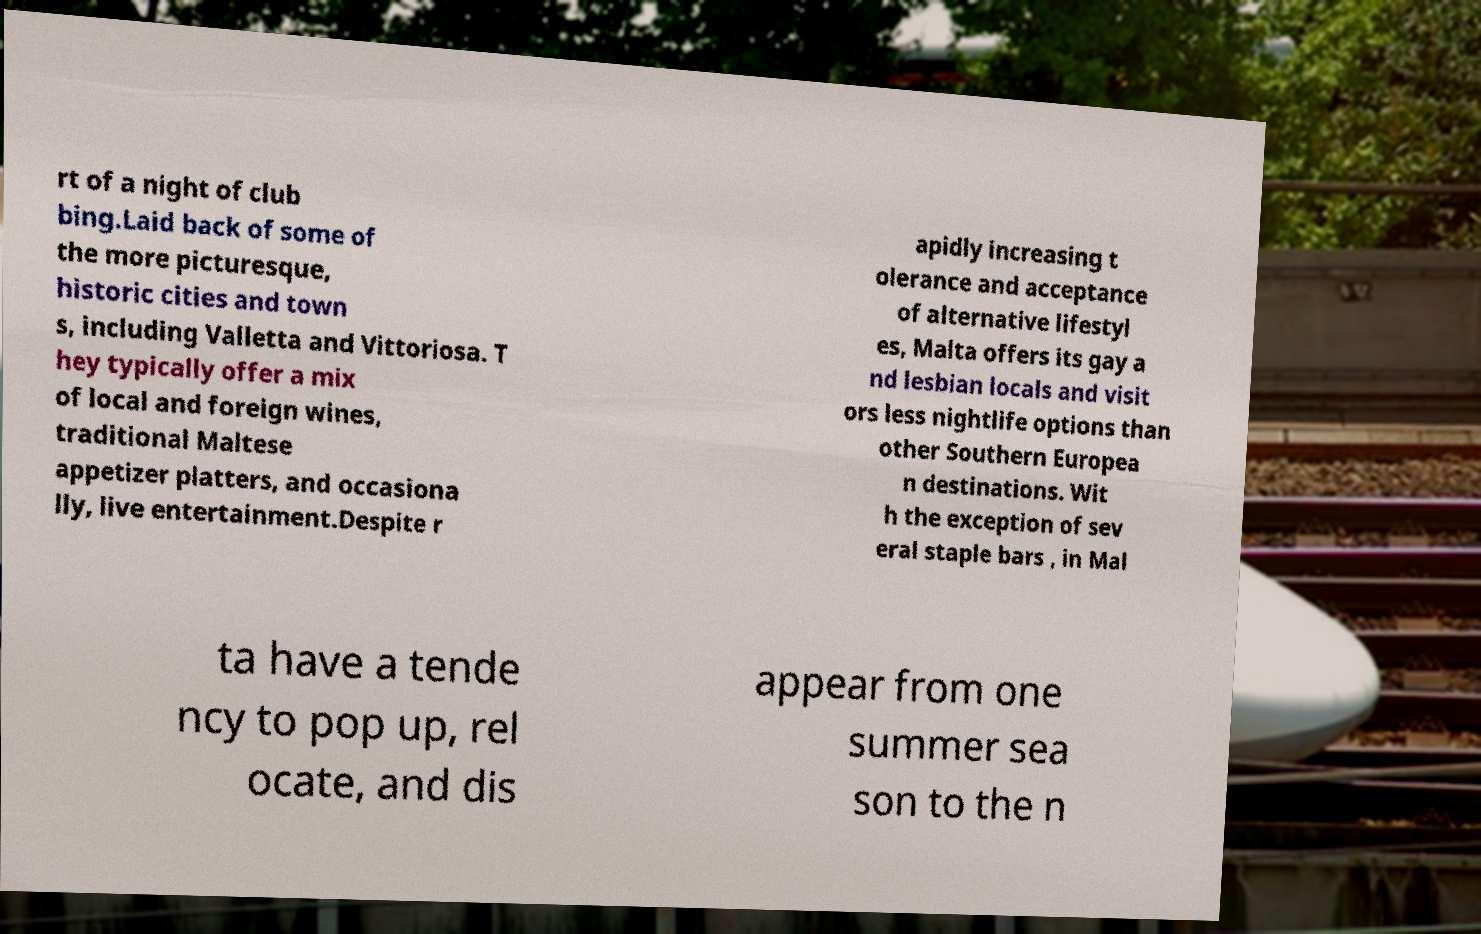What messages or text are displayed in this image? I need them in a readable, typed format. rt of a night of club bing.Laid back of some of the more picturesque, historic cities and town s, including Valletta and Vittoriosa. T hey typically offer a mix of local and foreign wines, traditional Maltese appetizer platters, and occasiona lly, live entertainment.Despite r apidly increasing t olerance and acceptance of alternative lifestyl es, Malta offers its gay a nd lesbian locals and visit ors less nightlife options than other Southern Europea n destinations. Wit h the exception of sev eral staple bars , in Mal ta have a tende ncy to pop up, rel ocate, and dis appear from one summer sea son to the n 